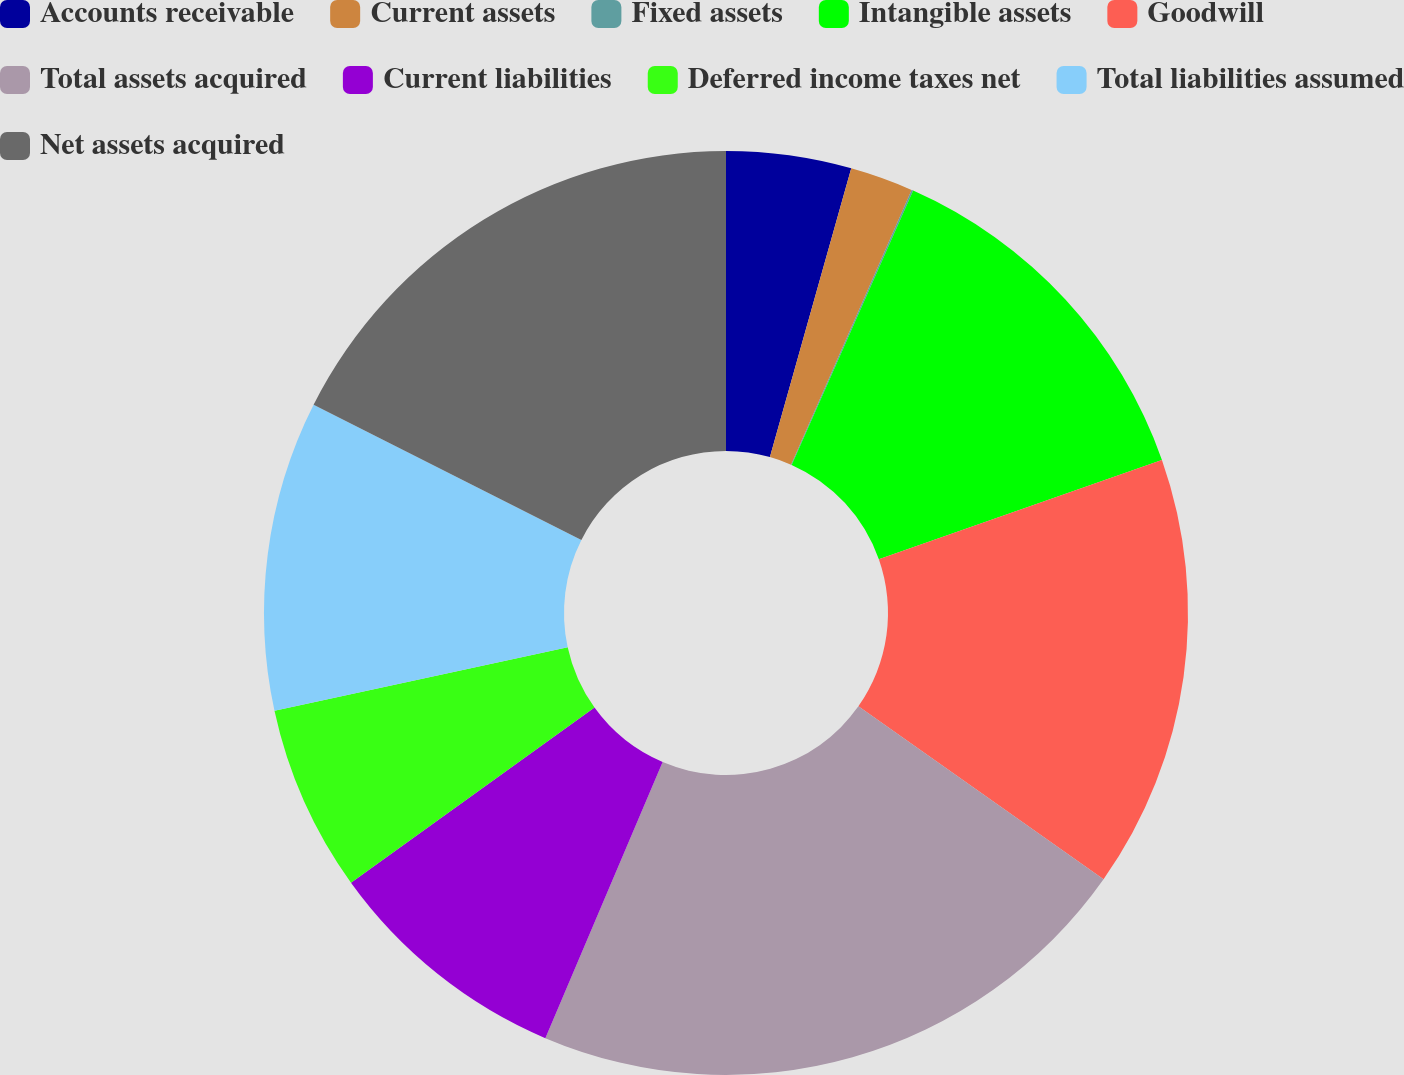Convert chart to OTSL. <chart><loc_0><loc_0><loc_500><loc_500><pie_chart><fcel>Accounts receivable<fcel>Current assets<fcel>Fixed assets<fcel>Intangible assets<fcel>Goodwill<fcel>Total assets acquired<fcel>Current liabilities<fcel>Deferred income taxes net<fcel>Total liabilities assumed<fcel>Net assets acquired<nl><fcel>4.37%<fcel>2.21%<fcel>0.06%<fcel>12.99%<fcel>15.15%<fcel>21.62%<fcel>8.68%<fcel>6.53%<fcel>10.84%<fcel>17.56%<nl></chart> 